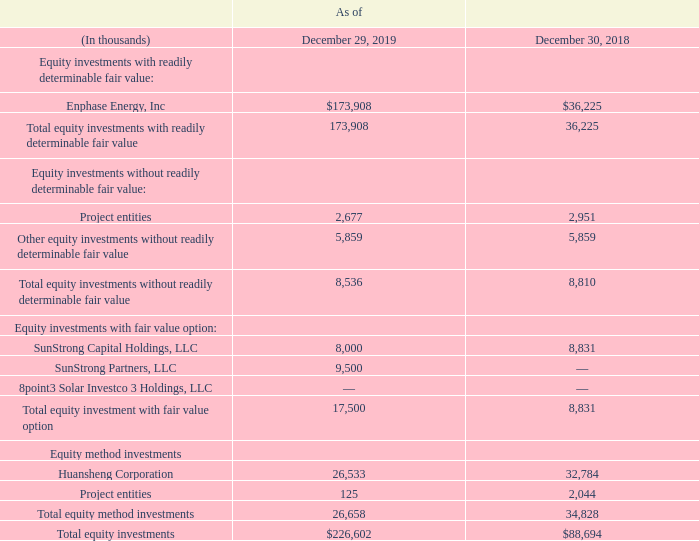Note 10. EQUITY INVESTMENTS
Our equity investments consist of equity investments with readily determinable fair value, investments without readily determinable fair value, equity investments accounted for using the fair value option, and equity method investments.
Our share of earnings (losses) from equity investments accounted for under the equity method is reflected as ‘‘Equity in earnings (losses) of unconsolidated investees’’ in our consolidated statements of operations. Mark-to-market gains and losses on equity investments with readily determinable fair value are reflected as ‘‘other, net’’ under other income (expense), net in our consolidated statements of operations. The carrying value of our equity investments, classified as ‘‘other long-term assets’’ on our consolidated balance sheets, are as follows:
What does the company's equity investments consist of? Consist of equity investments with readily determinable fair value, investments without readily determinable fair value, equity investments accounted for using the fair value option, and equity method investments. What is the share of earnings from equity investments accounted for under the equity method reflected as? ‘‘equity in earnings (losses) of unconsolidated investees’’ in our consolidated statements of operations. In which years is equity investments recorded for? 2019, 2018. Which year is the total equity investment with fair value option higher? 17,500 > 8,831
Answer: 2019. What was the change in total equity method investments from 2018 to 2019?
Answer scale should be: thousand. 26,658 - 34,828 
Answer: -8170. What was the percentage change in total equity investments from 2018 to 2019?
Answer scale should be: percent. ($226,602 - $88,694)/$88,694 
Answer: 155.49. 